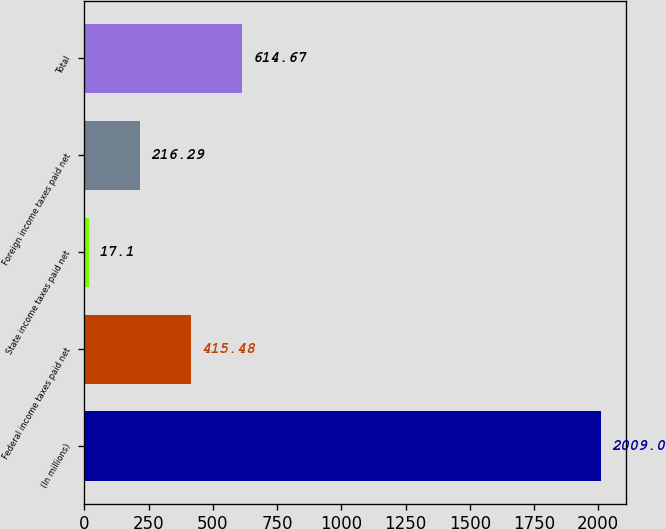<chart> <loc_0><loc_0><loc_500><loc_500><bar_chart><fcel>(In millions)<fcel>Federal income taxes paid net<fcel>State income taxes paid net<fcel>Foreign income taxes paid net<fcel>Total<nl><fcel>2009<fcel>415.48<fcel>17.1<fcel>216.29<fcel>614.67<nl></chart> 